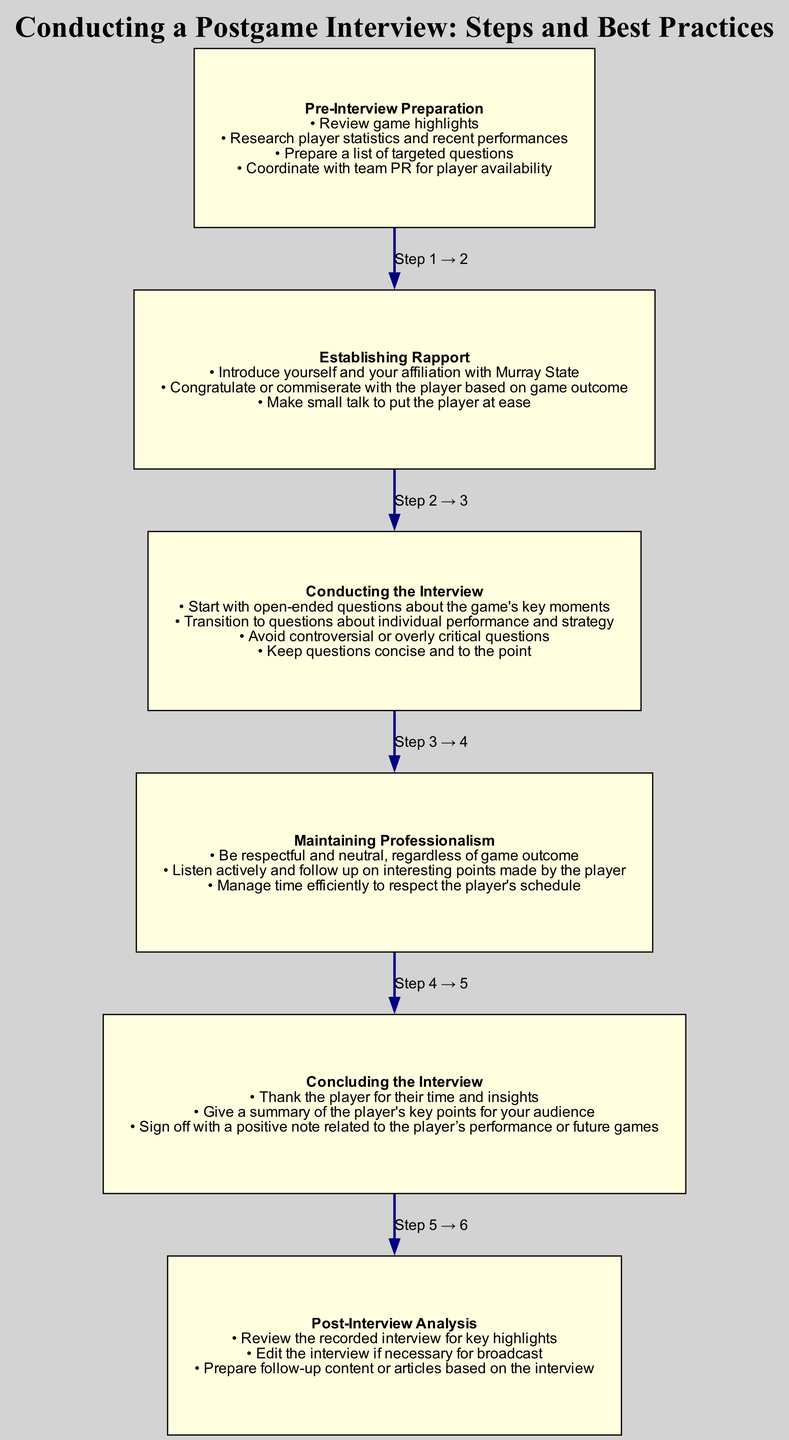What is the first step in the postgame interview process? The first step listed in the diagram is "Pre-Interview Preparation," which provides the foundational activities needed before conducting the interview.
Answer: Pre-Interview Preparation How many steps are there in the postgame interview instructions? The diagram lists a total of six distinct steps, indicating the flow of the interview process from preparation to analysis.
Answer: 6 What step comes immediately after "Establishing Rapport"? Following "Establishing Rapport," the next step outlined in the diagram is "Conducting the Interview," which focuses on how to engage with the player effectively.
Answer: Conducting the Interview What is emphasized in the "Maintaining Professionalism" step? This step stresses the importance of being respectful and neutral, suggesting that the interviewer should remain unbiased regardless of the game outcome.
Answer: Be respectful and neutral Which step includes thanking the player? The step that includes thanking the player is "Concluding the Interview," where the interviewer expresses gratitude for the player's time and insights as part of closing the discussion.
Answer: Concluding the Interview What should be avoided in the "Conducting the Interview" step? The diagram advises that controversial or overly critical questions should be avoided during the interview to maintain a positive atmosphere and rapport with the player.
Answer: Controversial or overly critical questions What is the main action in the "Post-Interview Analysis" step? The primary action in this step is to review the recorded interview for key highlights, ensuring that important moments and insights are captured for future use.
Answer: Review the recorded interview for key highlights How does the interviewer establish a connection with the player? The interviewer establishes a connection by introducing themselves, congratulating or commiserating based on the game's outcome, and making small talk to ease the player into the interview.
Answer: Introduce yourself and your affiliation with Murray State What is the key focus during the "Conducting the Interview" phase? The key focus during this phase is to start with open-ended questions about the game's key moments, allowing the player to express their thoughts and insights freely.
Answer: Open-ended questions about the game's key moments 